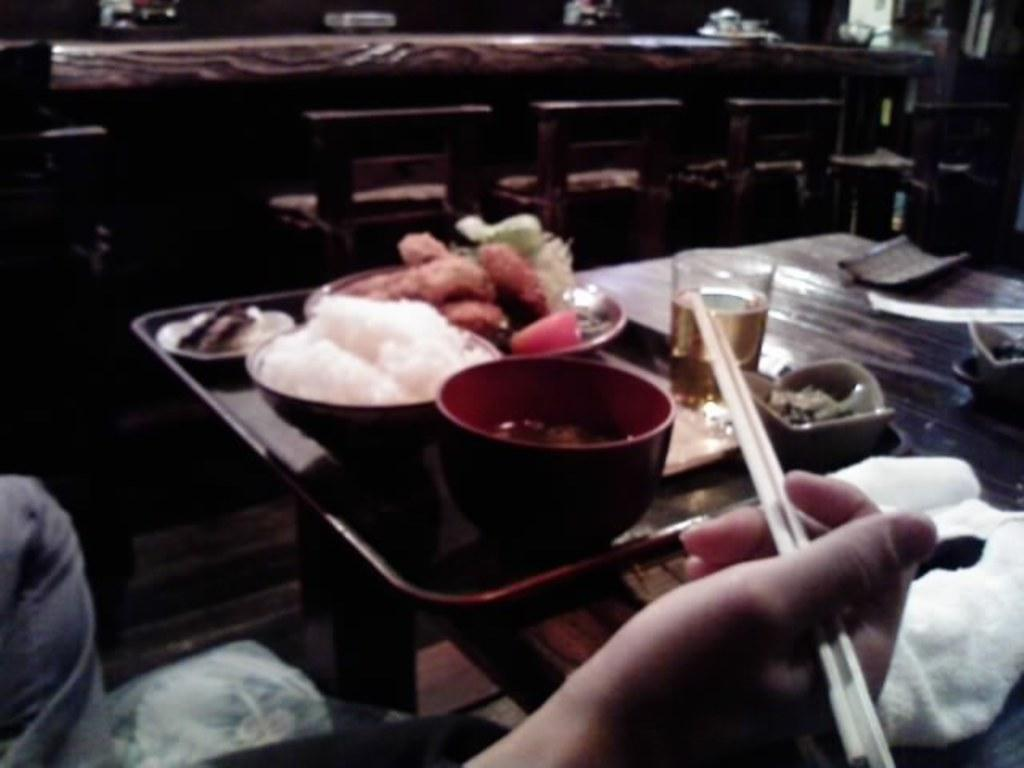What is the person in the left bottom corner of the image holding? The person is holding chopsticks in the image. What is on the table in the image? There is a tray on the table. What is on the tray? There is a bowl and a plate on the tray. What is in the bowl and on the plate? There is food in the bowl and on the plate. What type of glass is present in the image? There is a wine glass in the image. How many children are climbing the mountain in the image? There is no mountain or children present in the image. What type of root is growing near the food on the plate? There is no root present in the image. 